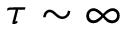Convert formula to latex. <formula><loc_0><loc_0><loc_500><loc_500>\tau \sim \infty</formula> 